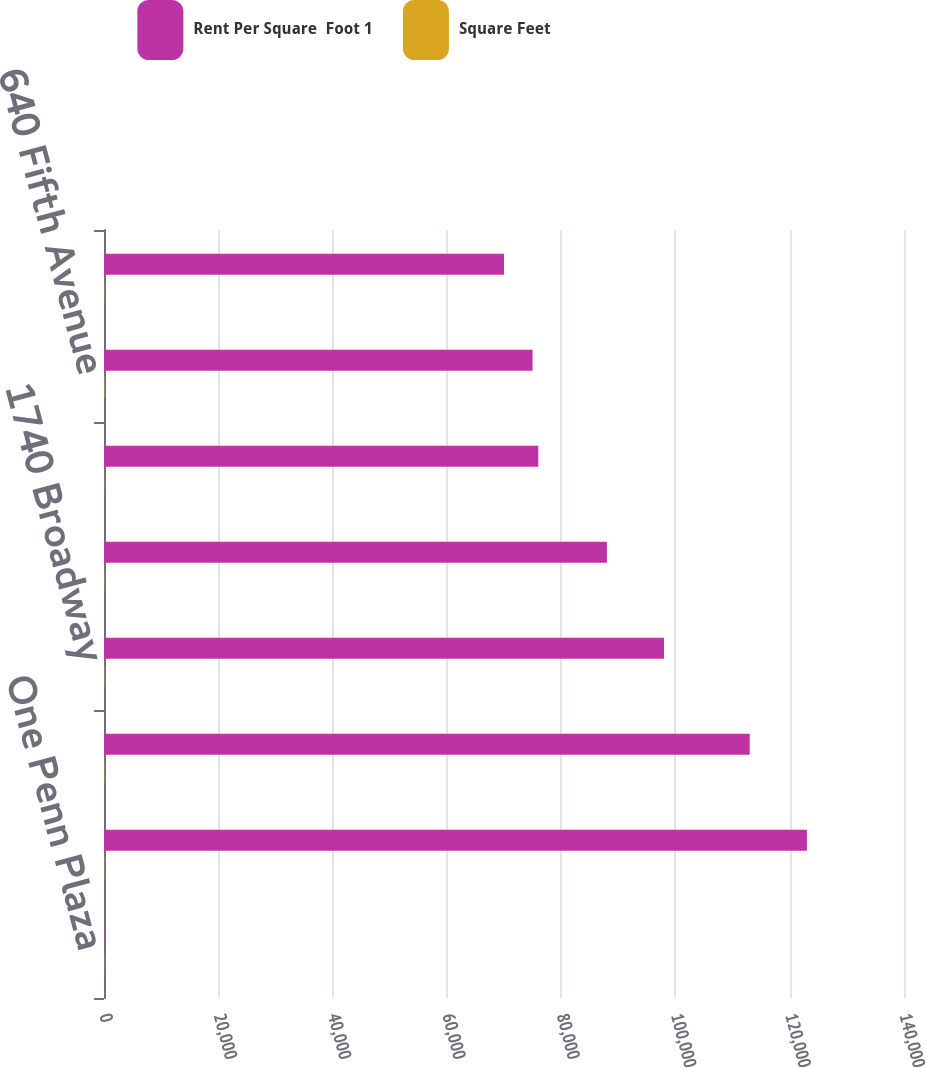Convert chart to OTSL. <chart><loc_0><loc_0><loc_500><loc_500><stacked_bar_chart><ecel><fcel>One Penn Plaza<fcel>150 East 58th Street<fcel>595 Madison<fcel>1740 Broadway<fcel>330 Madison Avenue (25<fcel>Two Penn Plaza<fcel>640 Fifth Avenue<fcel>888 Seventh Avenue<nl><fcel>Rent Per Square  Foot 1<fcel>69.79<fcel>123000<fcel>113000<fcel>98000<fcel>88000<fcel>76000<fcel>75000<fcel>70000<nl><fcel>Square Feet<fcel>39.57<fcel>45.71<fcel>53.83<fcel>54.42<fcel>46.02<fcel>38.12<fcel>69.79<fcel>47.74<nl></chart> 